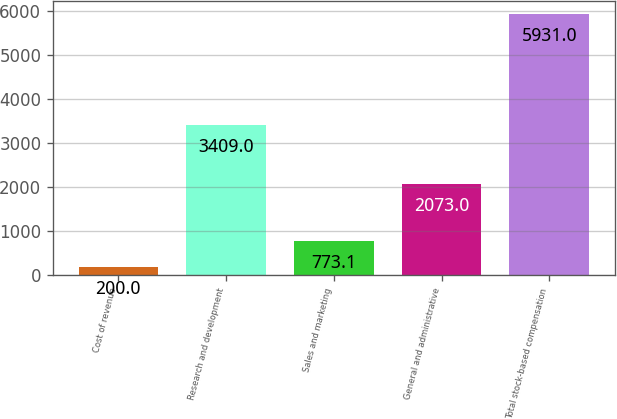Convert chart to OTSL. <chart><loc_0><loc_0><loc_500><loc_500><bar_chart><fcel>Cost of revenue<fcel>Research and development<fcel>Sales and marketing<fcel>General and administrative<fcel>Total stock-based compensation<nl><fcel>200<fcel>3409<fcel>773.1<fcel>2073<fcel>5931<nl></chart> 